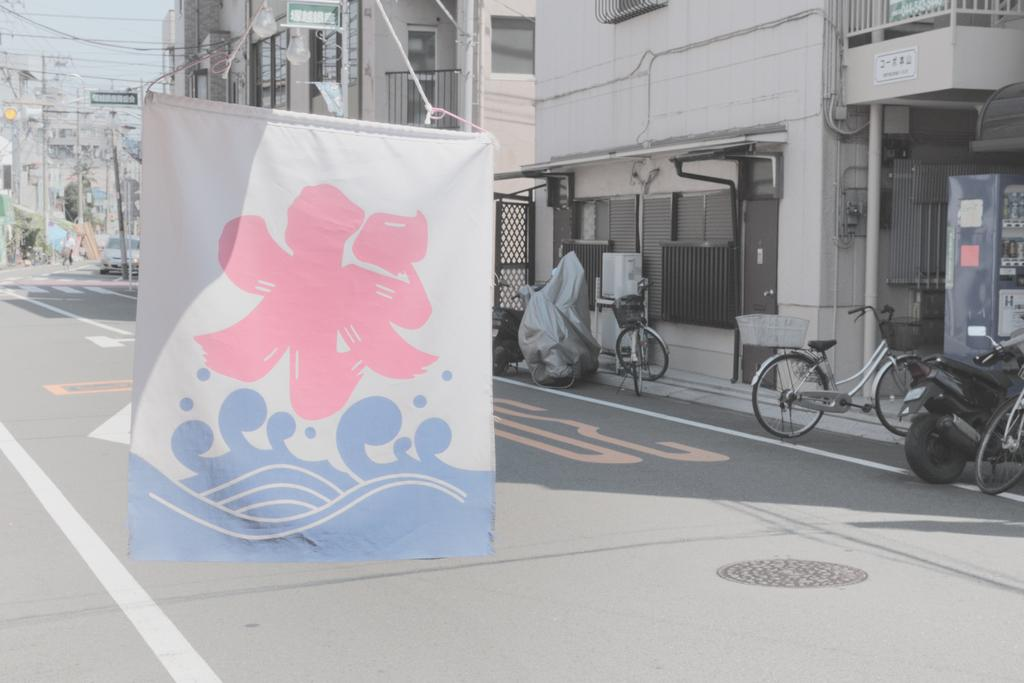What is hanging in the image? There is a banner in the image. How is the banner attached? The banner is attached with ropes. What can be seen on the ground in the image? There is a road visible in the image, and vehicles are parked on the surface. What is visible in the background of the image? There are buildings, wires, boards, windows, and the sky visible in the background of the image. What type of picture is hanging on the wall in the room shown in the image? There is no room or wall visible in the image; it only shows a banner, a road, vehicles, and the background. 